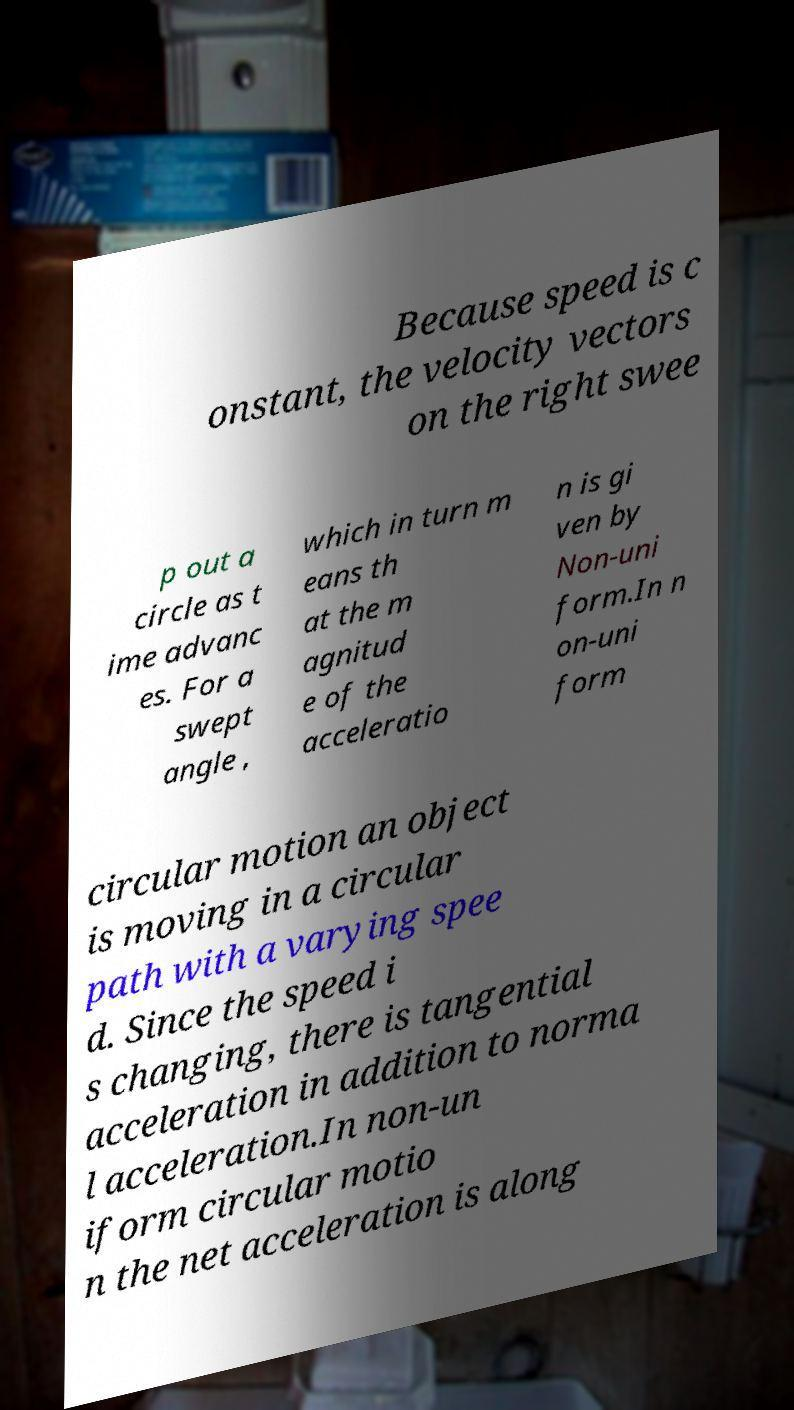Can you read and provide the text displayed in the image?This photo seems to have some interesting text. Can you extract and type it out for me? Because speed is c onstant, the velocity vectors on the right swee p out a circle as t ime advanc es. For a swept angle , which in turn m eans th at the m agnitud e of the acceleratio n is gi ven by Non-uni form.In n on-uni form circular motion an object is moving in a circular path with a varying spee d. Since the speed i s changing, there is tangential acceleration in addition to norma l acceleration.In non-un iform circular motio n the net acceleration is along 